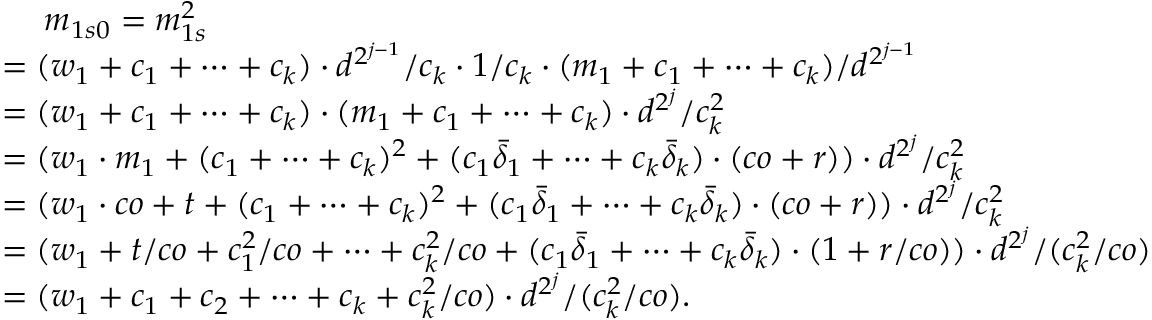<formula> <loc_0><loc_0><loc_500><loc_500>\begin{array} { r l } & { \quad \, m _ { 1 s 0 } = m _ { 1 s } ^ { 2 } } \\ & { = ( w _ { 1 } + c _ { 1 } + \cdots + c _ { k } ) \cdot d ^ { 2 ^ { j - 1 } } / c _ { k } \cdot 1 / c _ { k } \cdot ( m _ { 1 } + c _ { 1 } + \cdots + c _ { k } ) / d ^ { 2 ^ { j - 1 } } } \\ & { = ( w _ { 1 } + c _ { 1 } + \cdots + c _ { k } ) \cdot ( m _ { 1 } + c _ { 1 } + \cdots + c _ { k } ) \cdot d ^ { 2 ^ { j } } / c _ { k } ^ { 2 } } \\ & { = ( w _ { 1 } \cdot m _ { 1 } + ( c _ { 1 } + \cdots + c _ { k } ) ^ { 2 } + ( c _ { 1 } \bar { \delta } _ { 1 } + \cdots + c _ { k } \bar { \delta } _ { k } ) \cdot ( c o + r ) ) \cdot d ^ { 2 ^ { j } } / c _ { k } ^ { 2 } } \\ & { = ( w _ { 1 } \cdot c o + t + ( c _ { 1 } + \cdots + c _ { k } ) ^ { 2 } + ( c _ { 1 } \bar { \delta } _ { 1 } + \cdots + c _ { k } \bar { \delta } _ { k } ) \cdot ( c o + r ) ) \cdot d ^ { 2 ^ { j } } / c _ { k } ^ { 2 } } \\ & { = ( w _ { 1 } + t / c o + c _ { 1 } ^ { 2 } / c o + \cdots + c _ { k } ^ { 2 } / c o + ( c _ { 1 } \bar { \delta } _ { 1 } + \cdots + c _ { k } \bar { \delta } _ { k } ) \cdot ( 1 + r / c o ) ) \cdot d ^ { 2 ^ { j } } / ( c _ { k } ^ { 2 } / c o ) } \\ & { = ( w _ { 1 } + c _ { 1 } + c _ { 2 } + \cdots + c _ { k } + c _ { k } ^ { 2 } / c o ) \cdot d ^ { 2 ^ { j } } / ( c _ { k } ^ { 2 } / c o ) . } \end{array}</formula> 